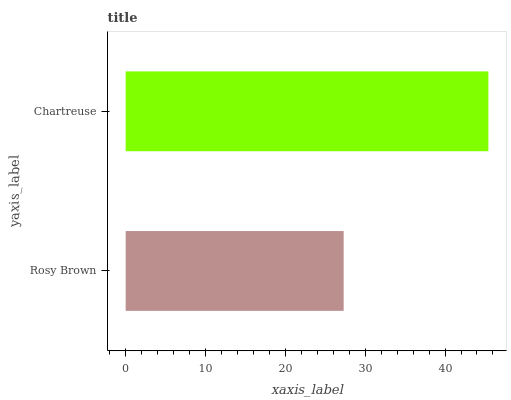Is Rosy Brown the minimum?
Answer yes or no. Yes. Is Chartreuse the maximum?
Answer yes or no. Yes. Is Chartreuse the minimum?
Answer yes or no. No. Is Chartreuse greater than Rosy Brown?
Answer yes or no. Yes. Is Rosy Brown less than Chartreuse?
Answer yes or no. Yes. Is Rosy Brown greater than Chartreuse?
Answer yes or no. No. Is Chartreuse less than Rosy Brown?
Answer yes or no. No. Is Chartreuse the high median?
Answer yes or no. Yes. Is Rosy Brown the low median?
Answer yes or no. Yes. Is Rosy Brown the high median?
Answer yes or no. No. Is Chartreuse the low median?
Answer yes or no. No. 